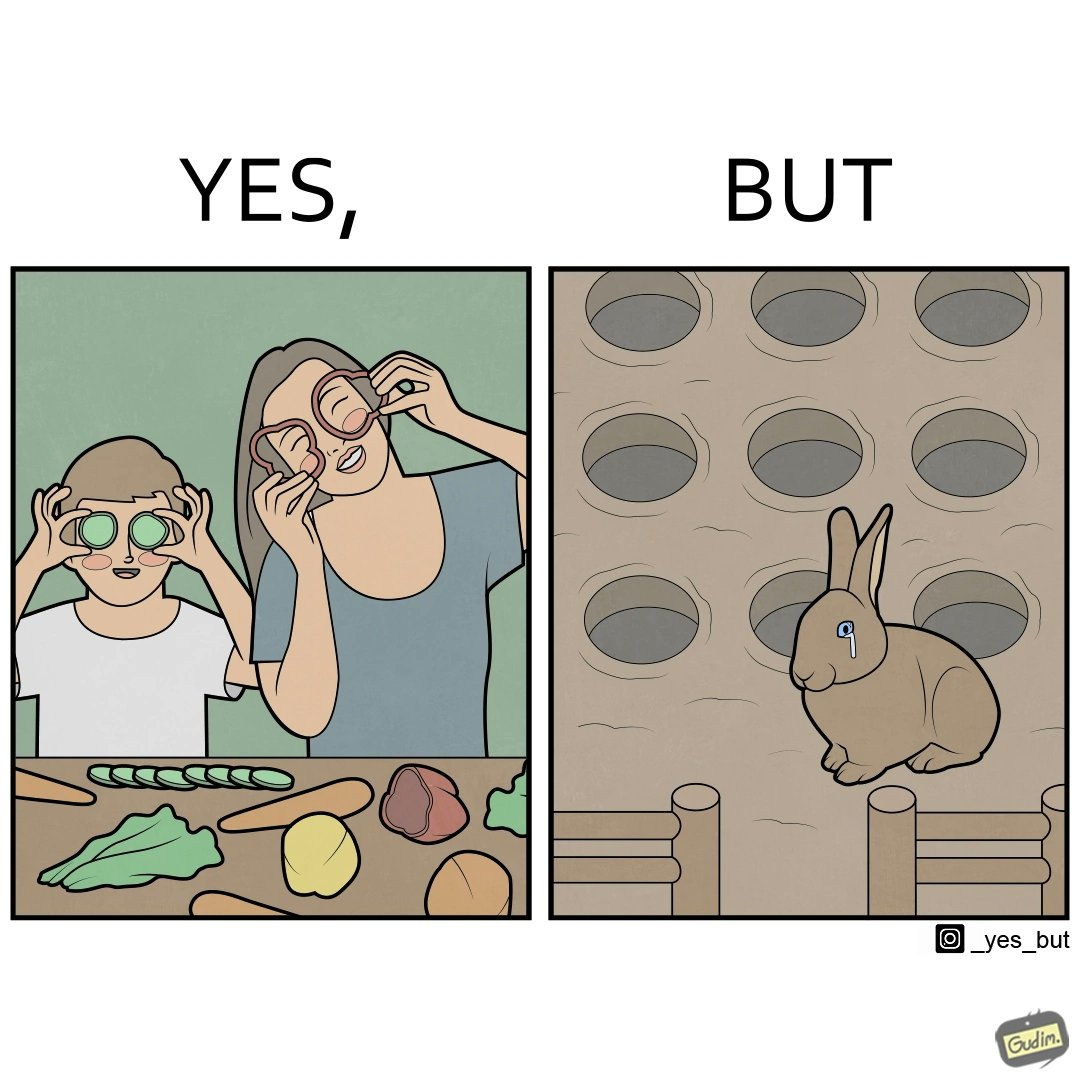What is shown in this image? The images are ironic since they show how on one hand humans choose to play with and waste foods like vegetables while the animals are unable to eat enough food and end up starving due to lack of food 